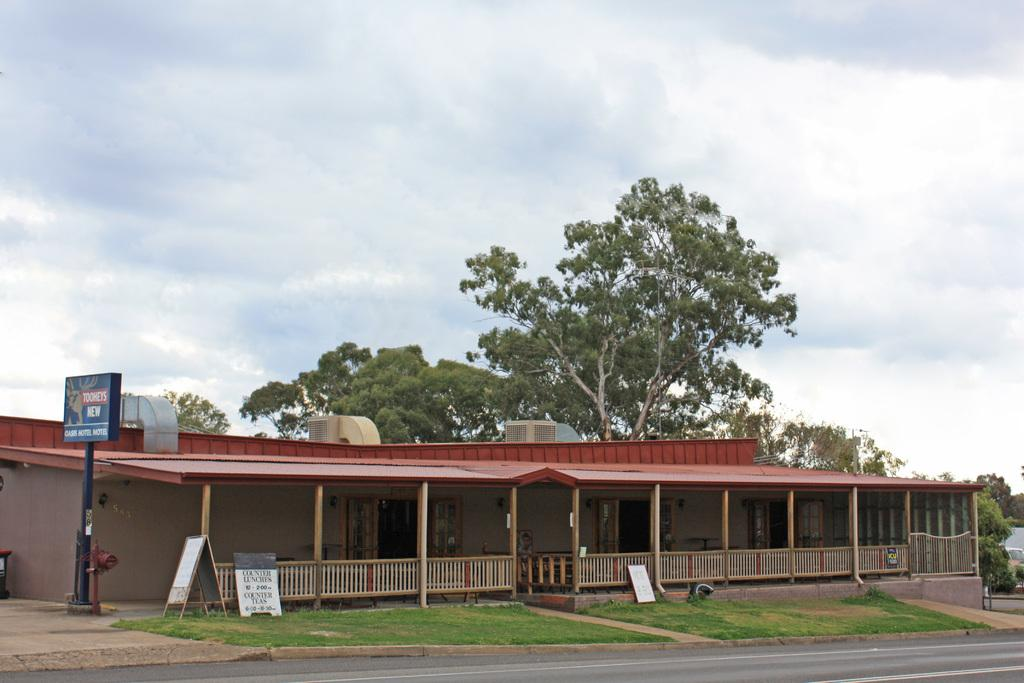What structure is visible in the image? There is a building in the image. What is placed in front of the building? There are hoardings in front of the building. What type of vegetation is present in front of the building? There is grass in front of the building. What can be seen in the background of the image? There are trees and clouds in the background of the image. What type of metal is used to construct the title in the image? There is no title present in the image, so it is not possible to determine what type of metal might be used. 